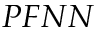<formula> <loc_0><loc_0><loc_500><loc_500>P F N N</formula> 